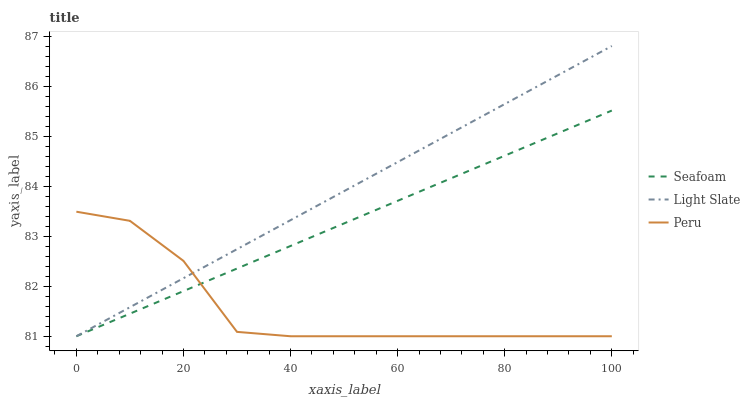Does Peru have the minimum area under the curve?
Answer yes or no. Yes. Does Light Slate have the maximum area under the curve?
Answer yes or no. Yes. Does Seafoam have the minimum area under the curve?
Answer yes or no. No. Does Seafoam have the maximum area under the curve?
Answer yes or no. No. Is Light Slate the smoothest?
Answer yes or no. Yes. Is Peru the roughest?
Answer yes or no. Yes. Is Peru the smoothest?
Answer yes or no. No. Is Seafoam the roughest?
Answer yes or no. No. Does Light Slate have the highest value?
Answer yes or no. Yes. Does Seafoam have the highest value?
Answer yes or no. No. Does Light Slate intersect Seafoam?
Answer yes or no. Yes. Is Light Slate less than Seafoam?
Answer yes or no. No. Is Light Slate greater than Seafoam?
Answer yes or no. No. 